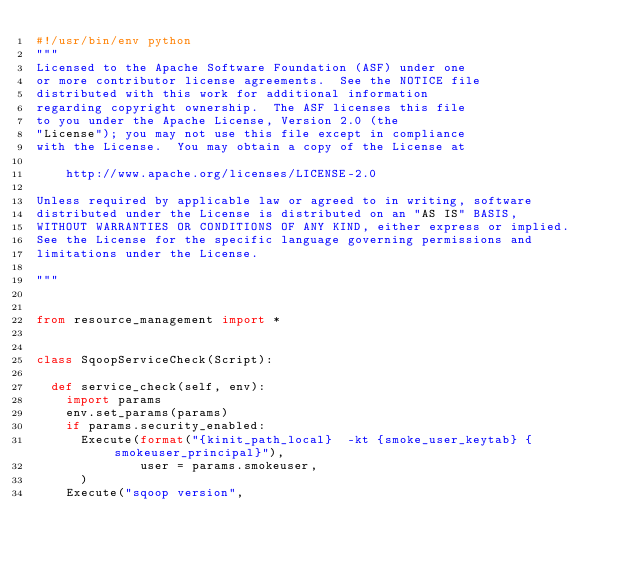Convert code to text. <code><loc_0><loc_0><loc_500><loc_500><_Python_>#!/usr/bin/env python
"""
Licensed to the Apache Software Foundation (ASF) under one
or more contributor license agreements.  See the NOTICE file
distributed with this work for additional information
regarding copyright ownership.  The ASF licenses this file
to you under the Apache License, Version 2.0 (the
"License"); you may not use this file except in compliance
with the License.  You may obtain a copy of the License at

    http://www.apache.org/licenses/LICENSE-2.0

Unless required by applicable law or agreed to in writing, software
distributed under the License is distributed on an "AS IS" BASIS,
WITHOUT WARRANTIES OR CONDITIONS OF ANY KIND, either express or implied.
See the License for the specific language governing permissions and
limitations under the License.

"""


from resource_management import *


class SqoopServiceCheck(Script):

  def service_check(self, env):
    import params
    env.set_params(params)
    if params.security_enabled:
      Execute(format("{kinit_path_local}  -kt {smoke_user_keytab} {smokeuser_principal}"),
              user = params.smokeuser,
      )
    Execute("sqoop version",</code> 